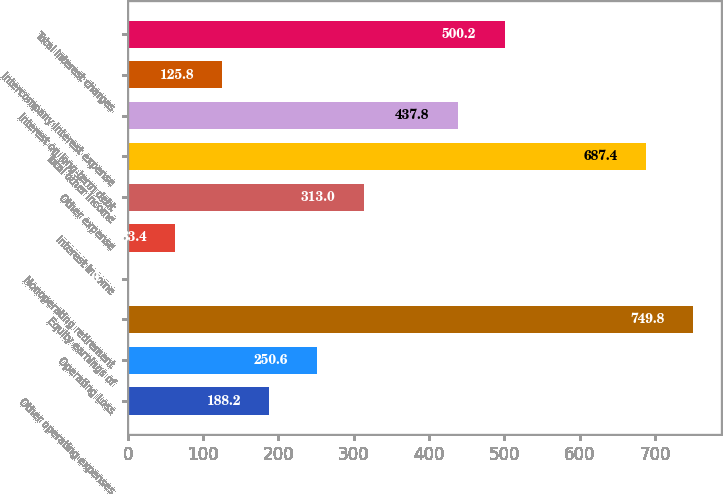<chart> <loc_0><loc_0><loc_500><loc_500><bar_chart><fcel>Other operating expenses<fcel>Operating Loss<fcel>Equity earnings of<fcel>Nonoperating retirement<fcel>Interest income<fcel>Other expense<fcel>Total other income<fcel>Interest on long-term debt<fcel>Intercompany interest expense<fcel>Total interest charges<nl><fcel>188.2<fcel>250.6<fcel>749.8<fcel>1<fcel>63.4<fcel>313<fcel>687.4<fcel>437.8<fcel>125.8<fcel>500.2<nl></chart> 